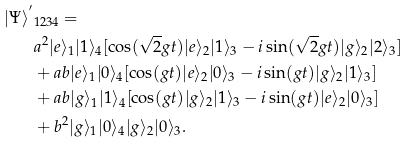<formula> <loc_0><loc_0><loc_500><loc_500>| \Psi \rangle ^ { ^ { \prime } } & _ { 1 2 3 4 } = \\ & a ^ { 2 } | e \rangle _ { 1 } | 1 \rangle _ { 4 } [ \cos ( \sqrt { 2 } g t ) | e \rangle _ { 2 } | 1 \rangle _ { 3 } - i \sin ( \sqrt { 2 } g t ) | g \rangle _ { 2 } | 2 \rangle _ { 3 } ] \\ & + a b | e \rangle _ { 1 } | 0 \rangle _ { 4 } [ \cos ( g t ) | e \rangle _ { 2 } | 0 \rangle _ { 3 } - i \sin ( g t ) | g \rangle _ { 2 } | 1 \rangle _ { 3 } ] \\ & + a b | g \rangle _ { 1 } | 1 \rangle _ { 4 } [ \cos ( g t ) | g \rangle _ { 2 } | 1 \rangle _ { 3 } - i \sin ( g t ) | e \rangle _ { 2 } | 0 \rangle _ { 3 } ] \\ & + b ^ { 2 } | g \rangle _ { 1 } | 0 \rangle _ { 4 } | g \rangle _ { 2 } | 0 \rangle _ { 3 } .</formula> 